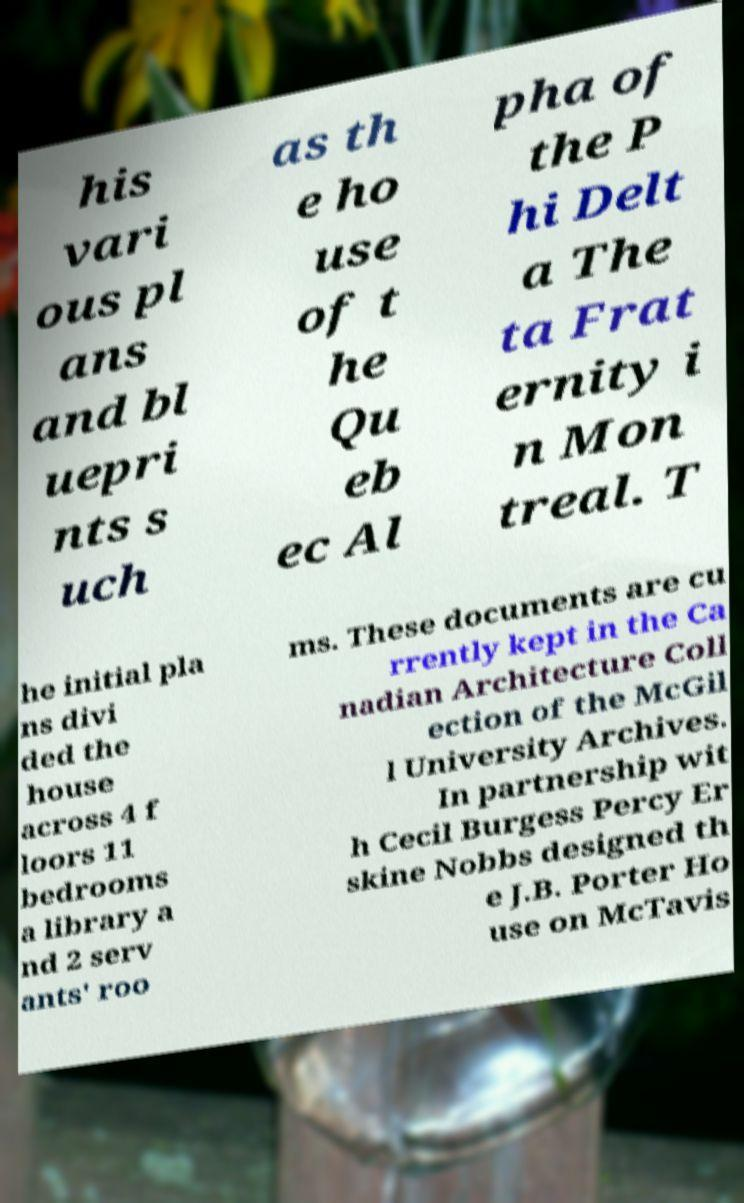I need the written content from this picture converted into text. Can you do that? his vari ous pl ans and bl uepri nts s uch as th e ho use of t he Qu eb ec Al pha of the P hi Delt a The ta Frat ernity i n Mon treal. T he initial pla ns divi ded the house across 4 f loors 11 bedrooms a library a nd 2 serv ants' roo ms. These documents are cu rrently kept in the Ca nadian Architecture Coll ection of the McGil l University Archives. In partnership wit h Cecil Burgess Percy Er skine Nobbs designed th e J.B. Porter Ho use on McTavis 